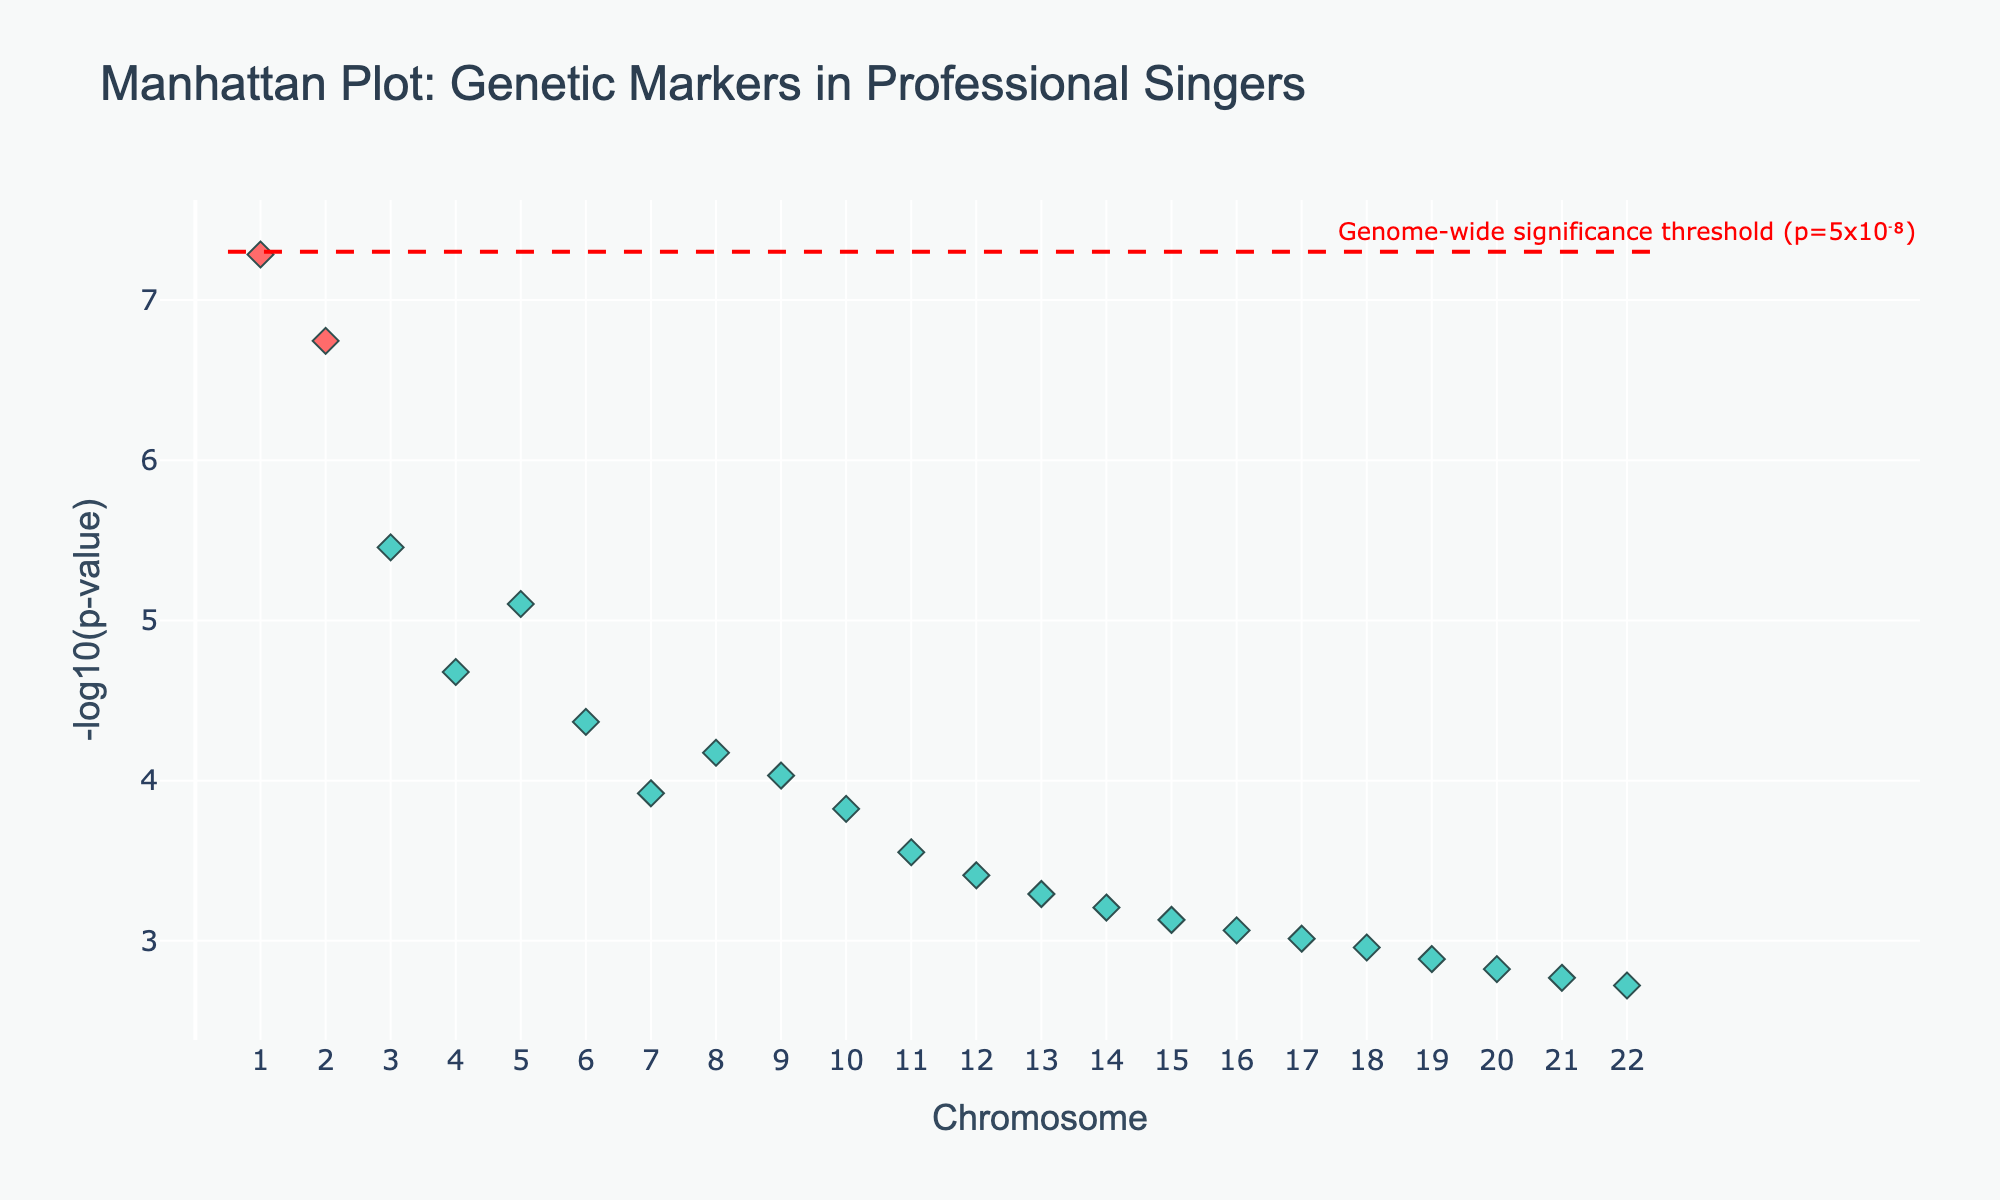What is the title of the plot? The title of the plot is typically found at the top of the figure and summarizes the main purpose or finding of the visualized data. Here, it reads "Manhattan Plot: Genetic Markers in Professional Singers."
Answer: Manhattan Plot: Genetic Markers in Professional Singers How many chromosomes are represented in this Manhattan plot? To determine the number of chromosomes, look at the x-axis labels, which range from 1 to 22, indicating that all 22 autosomes are represented.
Answer: 22 Which gene has the lowest p-value and on which chromosome is it located? The gene with the lowest p-value will have the highest -log10(p-value) on the y-axis. FOXP2 on Chromosome 1 has the lowest p-value of 5.2e-8, making it the most significant.
Answer: FOXP2 on Chromosome 1 What is the genome-wide significance threshold and how is it represented? The genome-wide significance threshold is marked by a horizontal line in the plot, often annotated for clarity. In this case, it is represented by a dashed red line at the y-value corresponding to -log10(5e-8).
Answer: p=5x10⁻⁸ Which chromosome has the most significant genetic marker below the threshold? To identify the chromosome with the most significant genetic marker below the p-value threshold, find the chromosome with a data point above the dashed red line. The marker for FOXP2 on Chromosome 1 meets this criterion.
Answer: Chromosome 1 Compare the significance of genes ROBO1 and MEF2C. Which one is more significant? To compare the significance, we examine the y-values (-log10(p-value)) of the two genes. ROBO1 has a p-value of 3.5e-6 and MEF2C has a p-value of 7.9e-6. Since -log10(3.5e-6) > -log10(7.9e-6), ROBO1 is more significant.
Answer: ROBO1 What is the range of p-values shown in the plot? The range of p-values can be found by identifying the highest and lowest points on the y-axis (the -log10(p-value)). The lowest p-value is 5.2e-8, and the highest is 1.9e-3, giving the range of p-values.
Answer: 5.2e-8 to 1.9e-3 Are there any chromosomes without significant genetic markers below the threshold? By observing the plot, chromosomes with markers above and below the significance threshold line can be noted. Only Chromosome 1 has markers below the genome-wide significance threshold, and all others do not.
Answer: Yes, all chromosomes except Chromosome 1 How are the significant genetic markers visually distinguished in the plot? Significant genetic markers (p<1e-6) are highlighted in a unique color (usually different from non-significant ones) and are denoted with red here, whereas others are in teal.
Answer: By color (red for significant) Which gene has the highest p-value, and how can it be identified on the plot? The gene with the highest p-value will have the smallest -log10(p-value) on the y-axis. COMT on Chromosome 22 with a p-value of 1.9e-3 is the least significant.
Answer: COMT on Chromosome 22 